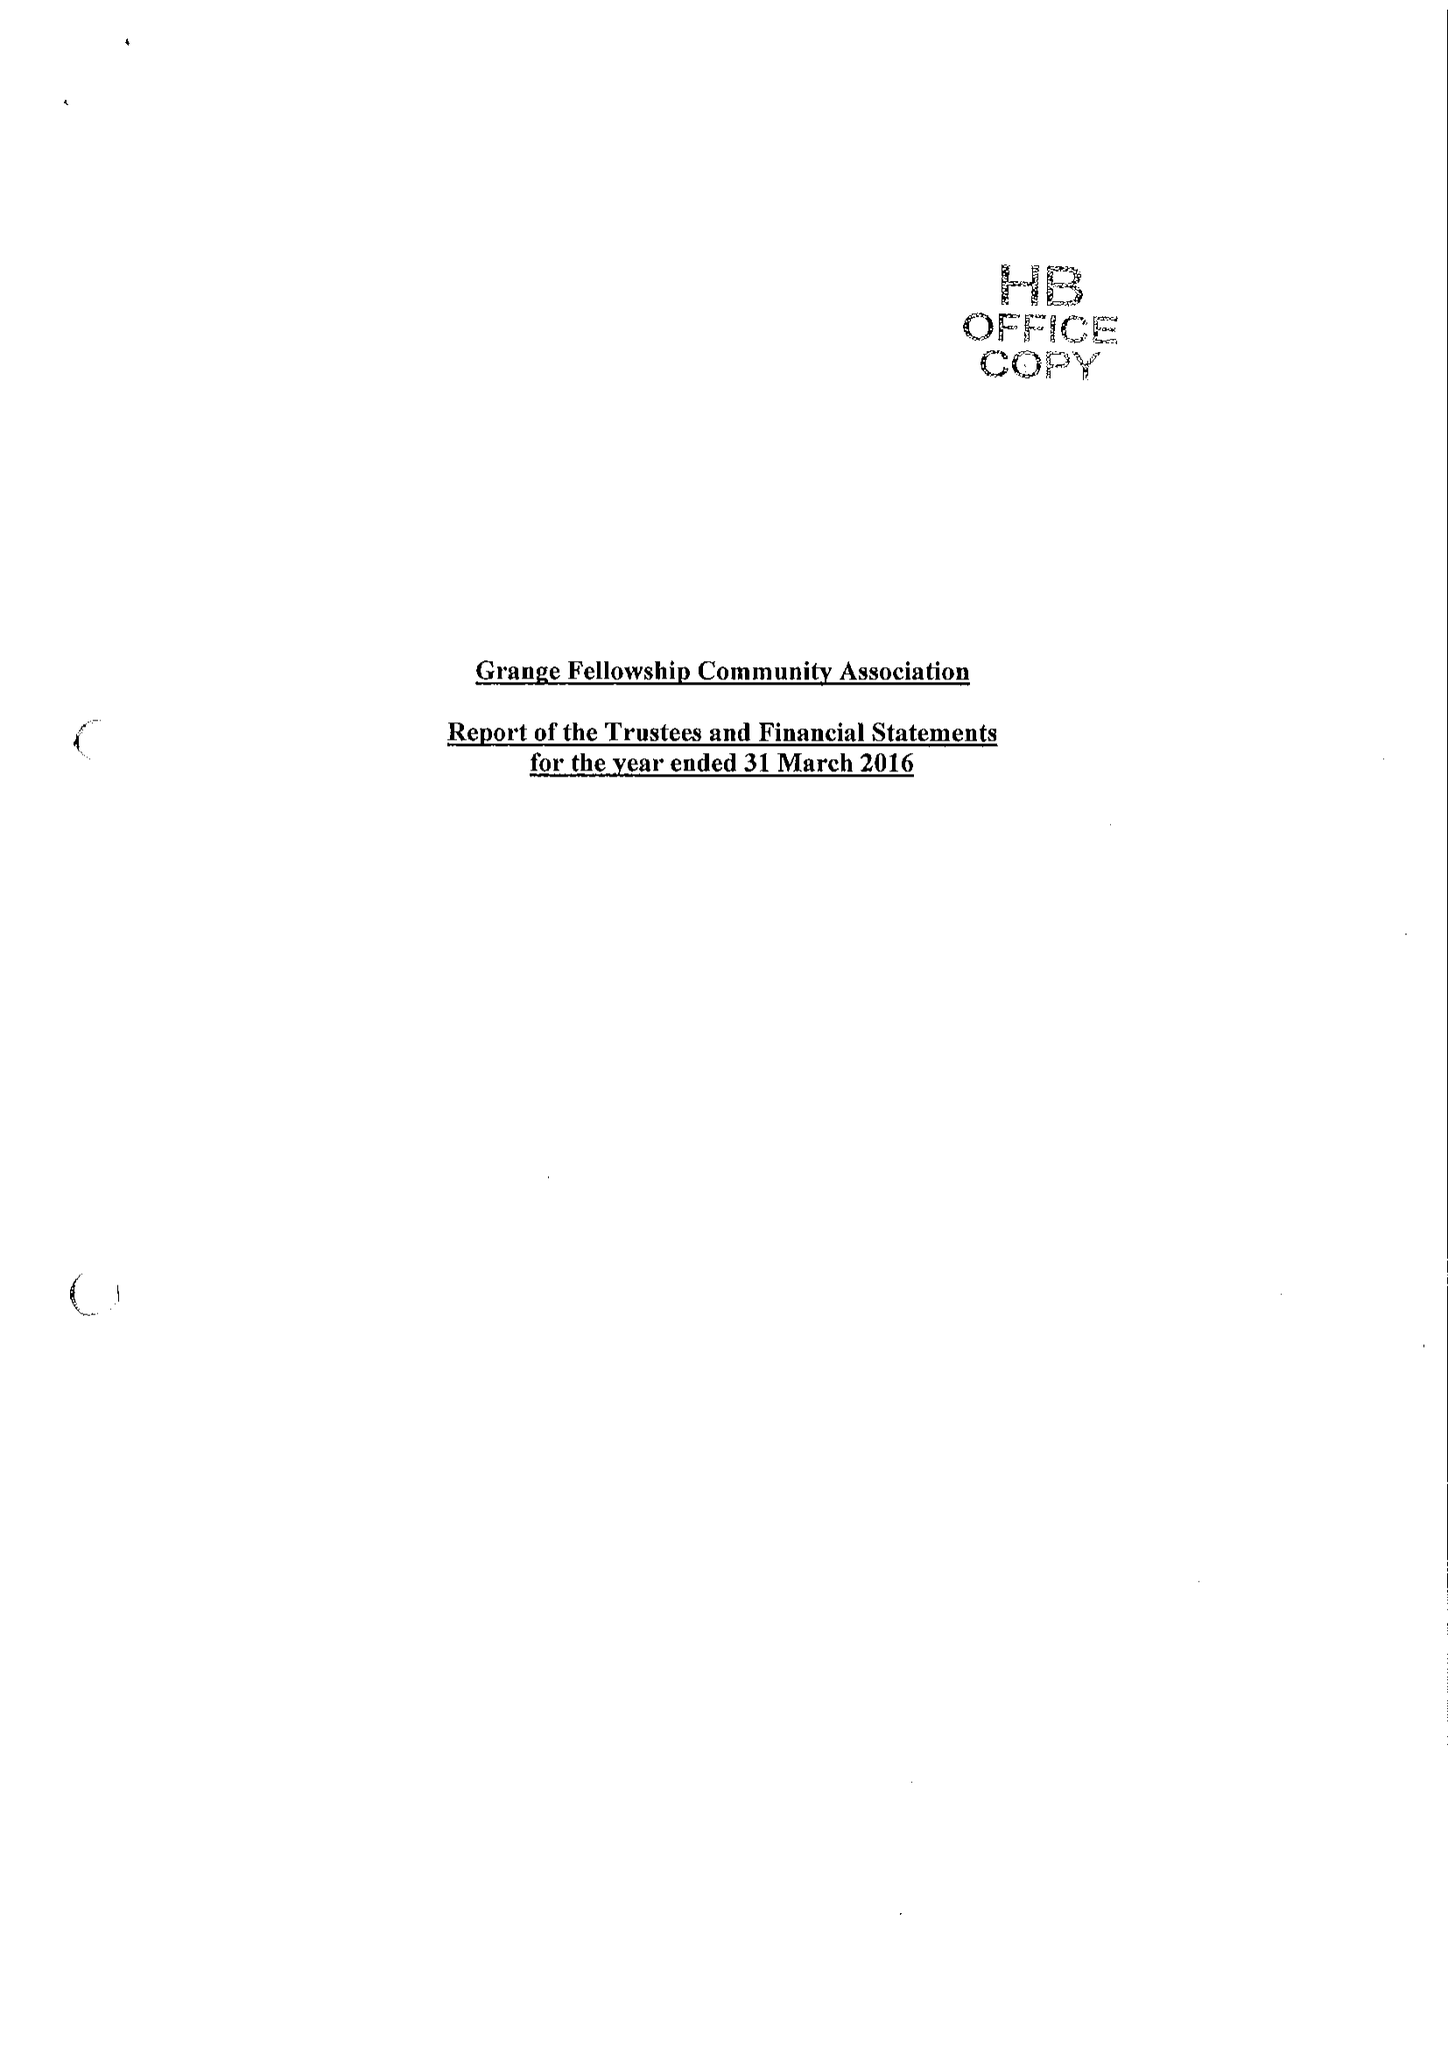What is the value for the address__postcode?
Answer the question using a single word or phrase. SG6 4NG 